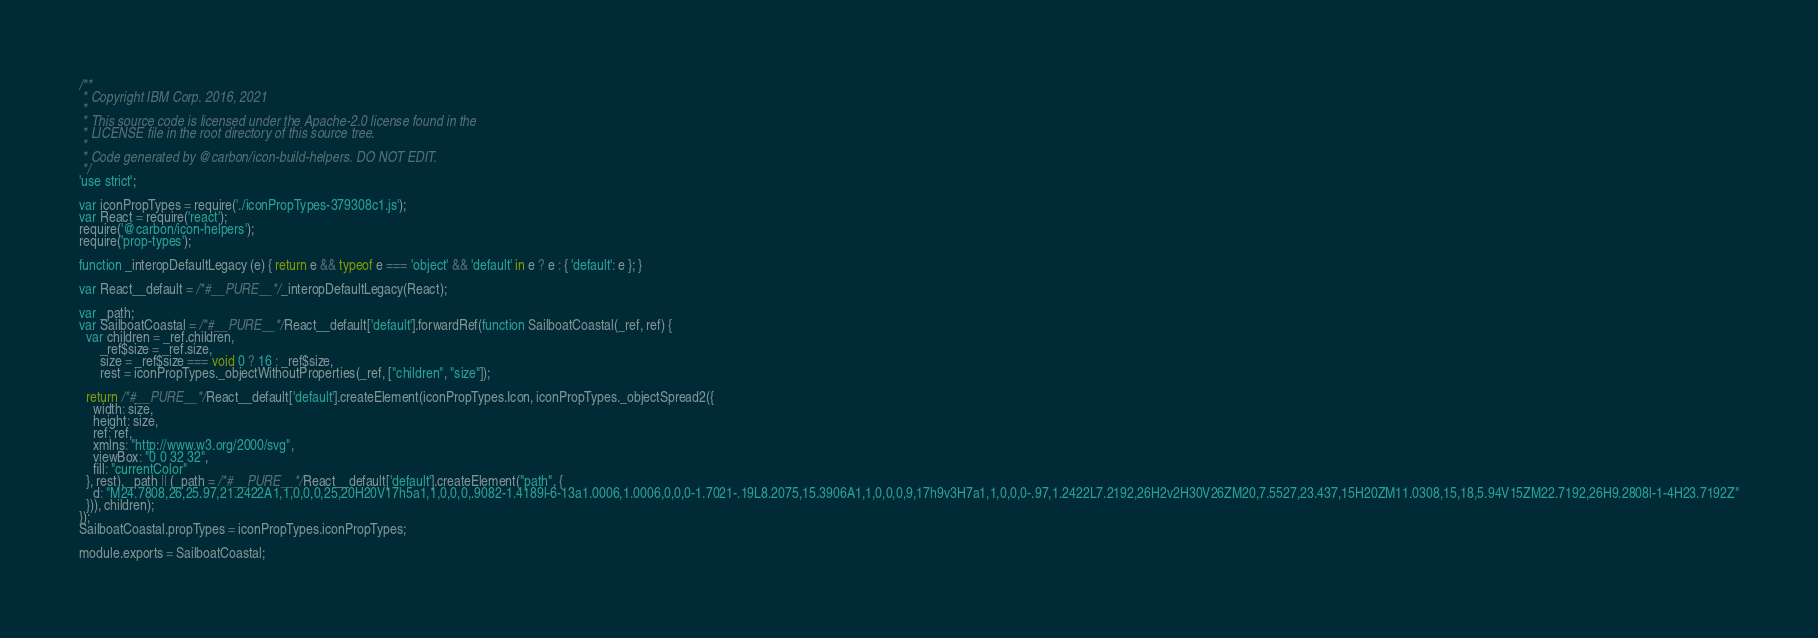<code> <loc_0><loc_0><loc_500><loc_500><_JavaScript_>/**
 * Copyright IBM Corp. 2016, 2021
 *
 * This source code is licensed under the Apache-2.0 license found in the
 * LICENSE file in the root directory of this source tree.
 *
 * Code generated by @carbon/icon-build-helpers. DO NOT EDIT.
 */
'use strict';

var iconPropTypes = require('./iconPropTypes-379308c1.js');
var React = require('react');
require('@carbon/icon-helpers');
require('prop-types');

function _interopDefaultLegacy (e) { return e && typeof e === 'object' && 'default' in e ? e : { 'default': e }; }

var React__default = /*#__PURE__*/_interopDefaultLegacy(React);

var _path;
var SailboatCoastal = /*#__PURE__*/React__default['default'].forwardRef(function SailboatCoastal(_ref, ref) {
  var children = _ref.children,
      _ref$size = _ref.size,
      size = _ref$size === void 0 ? 16 : _ref$size,
      rest = iconPropTypes._objectWithoutProperties(_ref, ["children", "size"]);

  return /*#__PURE__*/React__default['default'].createElement(iconPropTypes.Icon, iconPropTypes._objectSpread2({
    width: size,
    height: size,
    ref: ref,
    xmlns: "http://www.w3.org/2000/svg",
    viewBox: "0 0 32 32",
    fill: "currentColor"
  }, rest), _path || (_path = /*#__PURE__*/React__default['default'].createElement("path", {
    d: "M24.7808,26,25.97,21.2422A1,1,0,0,0,25,20H20V17h5a1,1,0,0,0,.9082-1.4189l-6-13a1.0006,1.0006,0,0,0-1.7021-.19L8.2075,15.3906A1,1,0,0,0,9,17h9v3H7a1,1,0,0,0-.97,1.2422L7.2192,26H2v2H30V26ZM20,7.5527,23.437,15H20ZM11.0308,15,18,5.94V15ZM22.7192,26H9.2808l-1-4H23.7192Z"
  })), children);
});
SailboatCoastal.propTypes = iconPropTypes.iconPropTypes;

module.exports = SailboatCoastal;
</code> 